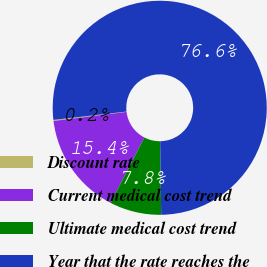<chart> <loc_0><loc_0><loc_500><loc_500><pie_chart><fcel>Discount rate<fcel>Current medical cost trend<fcel>Ultimate medical cost trend<fcel>Year that the rate reaches the<nl><fcel>0.16%<fcel>15.45%<fcel>7.8%<fcel>76.59%<nl></chart> 